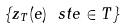Convert formula to latex. <formula><loc_0><loc_0><loc_500><loc_500>\{ z _ { T } ( e ) \ s t e \in T \}</formula> 